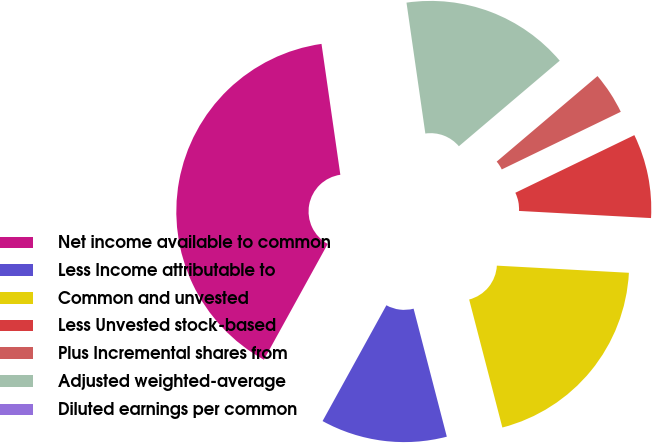Convert chart. <chart><loc_0><loc_0><loc_500><loc_500><pie_chart><fcel>Net income available to common<fcel>Less Income attributable to<fcel>Common and unvested<fcel>Less Unvested stock-based<fcel>Plus Incremental shares from<fcel>Adjusted weighted-average<fcel>Diluted earnings per common<nl><fcel>39.71%<fcel>12.06%<fcel>20.1%<fcel>8.04%<fcel>4.02%<fcel>16.08%<fcel>0.0%<nl></chart> 